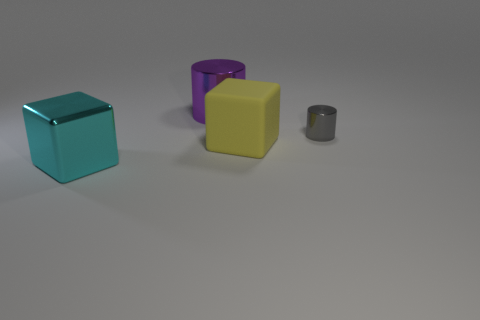Add 3 metal things. How many objects exist? 7 Add 3 big cyan metal cubes. How many big cyan metal cubes exist? 4 Subtract 1 gray cylinders. How many objects are left? 3 Subtract all large green metallic balls. Subtract all big cyan cubes. How many objects are left? 3 Add 4 large yellow blocks. How many large yellow blocks are left? 5 